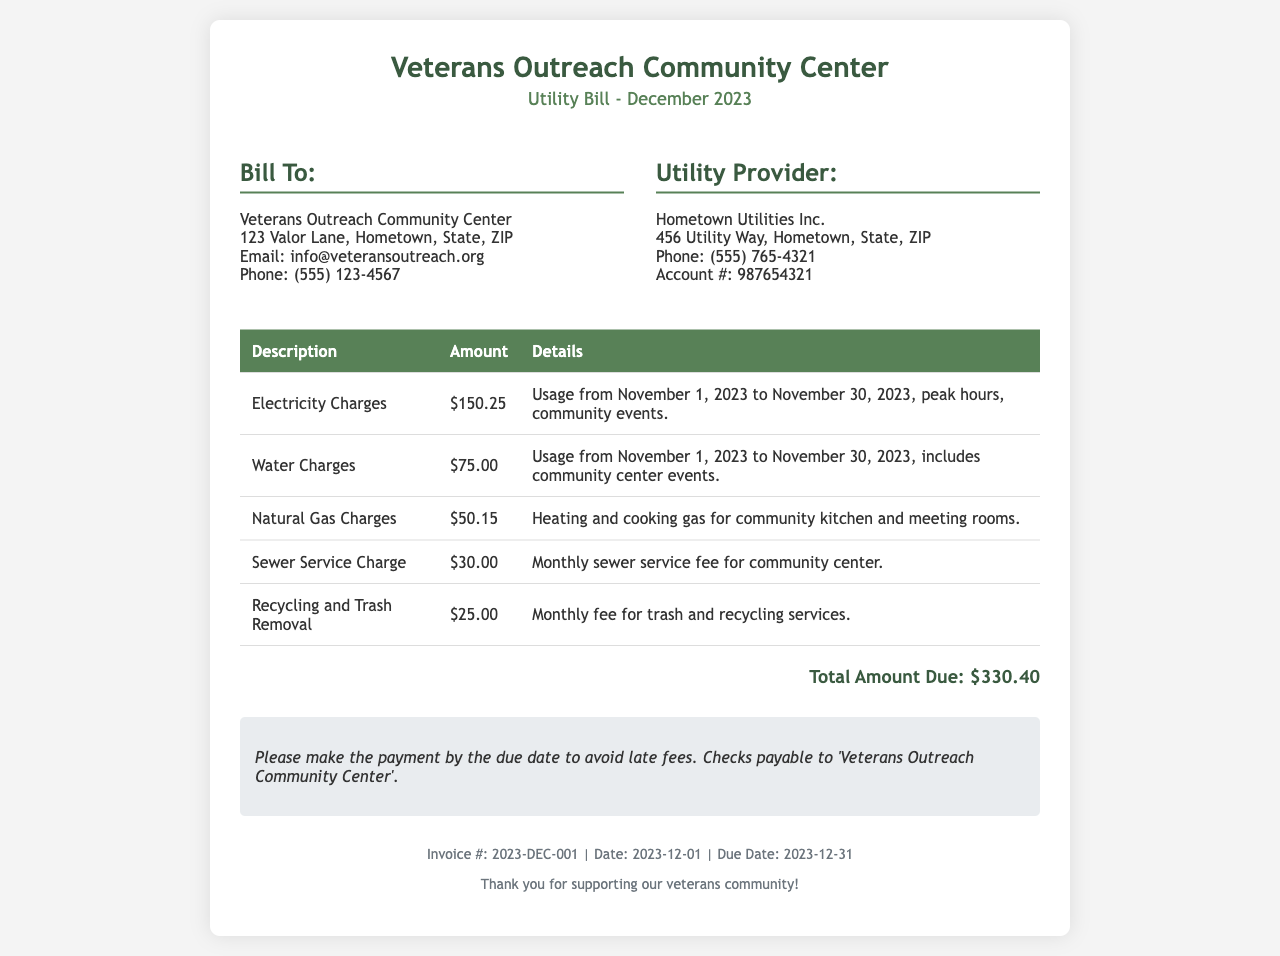What is the total amount due? The total amount due is stated at the bottom of the invoice, totaling all the charges together.
Answer: $330.40 Who is the utility provider? The utility provider is listed under the utility provider section of the document.
Answer: Hometown Utilities Inc What date is the invoice dated? The date of the invoice is mentioned in the footer section.
Answer: 2023-12-01 What is the account number? The account number is provided under the utility provider section.
Answer: 987654321 How much is charged for electricity? The charge for electricity is specified in the charges table.
Answer: $150.25 What are the payment instructions? Payment instructions are provided in a specific section of the document, guiding how to pay.
Answer: Checks payable to 'Veterans Outreach Community Center' How much is the water charge? The water charge is listed as a separate item in the charges table.
Answer: $75.00 What is the due date for the bill? The due date is found in the footer section of the document.
Answer: 2023-12-31 What service does the sewer service charge cover? The sewer service charge is detailed in the charges table, explaining what it covers.
Answer: Monthly sewer service fee for community center 